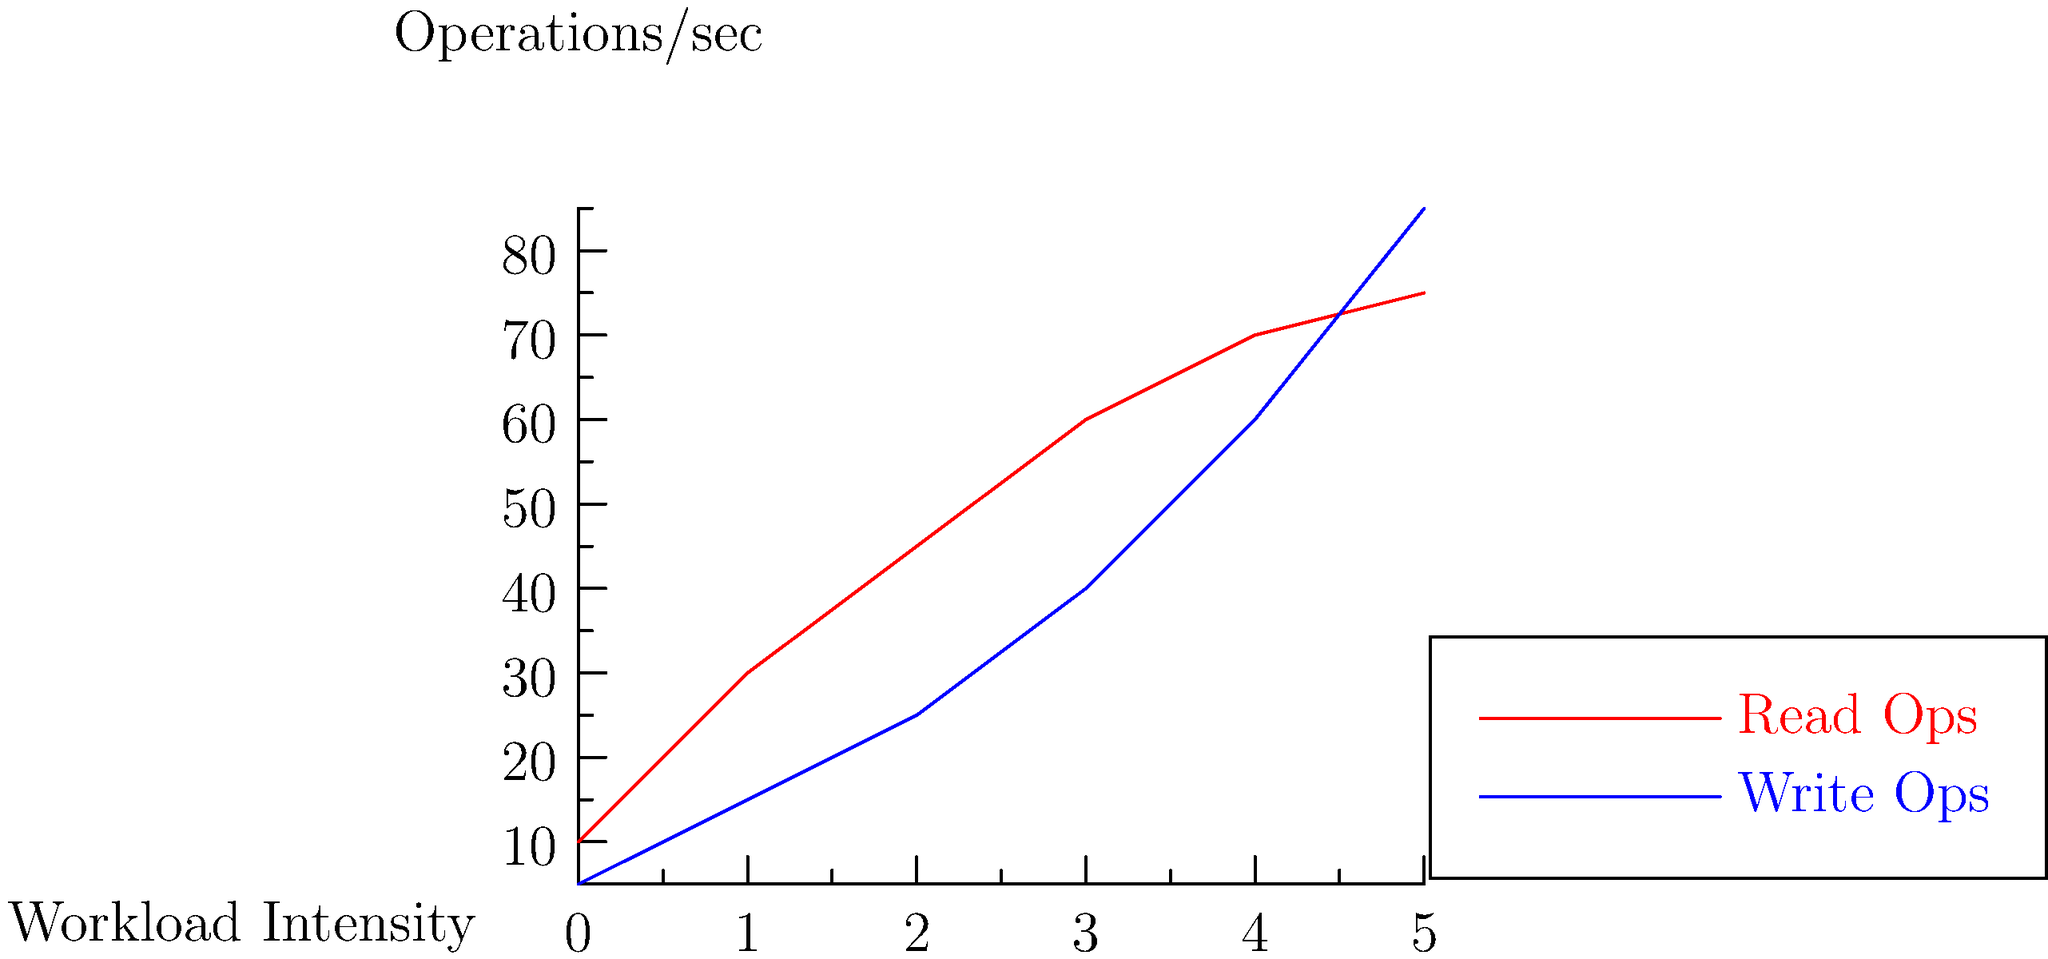Analyze the performance graph of Redis read and write operations under different workload intensities. At which workload intensity level do write operations start to outperform read operations in terms of operations per second? To determine when write operations outperform read operations, we need to analyze the graph step-by-step:

1. The x-axis represents workload intensity, while the y-axis shows operations per second.
2. The red line represents read operations, and the blue line represents write operations.
3. We need to find the point where the blue line crosses above the red line.

Let's examine the graph at each workload intensity level:

- At 0: Read ops ≈ 10, Write ops ≈ 5
- At 1: Read ops ≈ 30, Write ops ≈ 15
- At 2: Read ops ≈ 45, Write ops ≈ 25
- At 3: Read ops ≈ 60, Write ops ≈ 40
- At 4: Read ops ≈ 70, Write ops ≈ 60
- At 5: Read ops ≈ 75, Write ops ≈ 85

We can see that between workload intensity 4 and 5, the write operations line (blue) crosses above the read operations line (red). To be more precise, we can estimate that this occurs at approximately workload intensity 4.5.

This behavior is typical in Redis under high workload scenarios, where write operations can become more efficient than read operations due to various factors such as caching mechanisms and the nature of Redis' in-memory data structure.
Answer: 4.5 